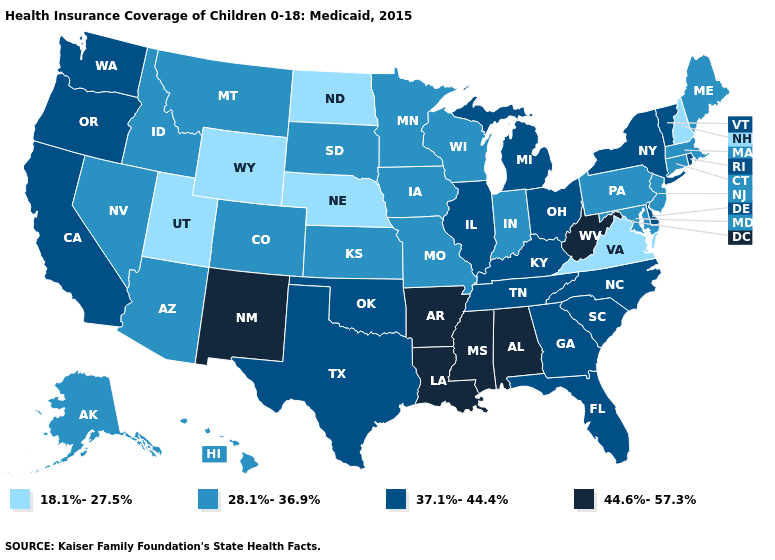How many symbols are there in the legend?
Quick response, please. 4. Among the states that border Louisiana , which have the highest value?
Write a very short answer. Arkansas, Mississippi. What is the highest value in the Northeast ?
Keep it brief. 37.1%-44.4%. Which states have the highest value in the USA?
Keep it brief. Alabama, Arkansas, Louisiana, Mississippi, New Mexico, West Virginia. Does Ohio have a higher value than West Virginia?
Quick response, please. No. What is the highest value in the MidWest ?
Answer briefly. 37.1%-44.4%. What is the lowest value in the USA?
Short answer required. 18.1%-27.5%. Does Rhode Island have the same value as Kansas?
Quick response, please. No. Among the states that border New York , does Connecticut have the highest value?
Answer briefly. No. Does Washington have the same value as Georgia?
Short answer required. Yes. Among the states that border Virginia , which have the highest value?
Concise answer only. West Virginia. What is the value of Idaho?
Short answer required. 28.1%-36.9%. What is the lowest value in the South?
Write a very short answer. 18.1%-27.5%. How many symbols are there in the legend?
Concise answer only. 4. Is the legend a continuous bar?
Answer briefly. No. 